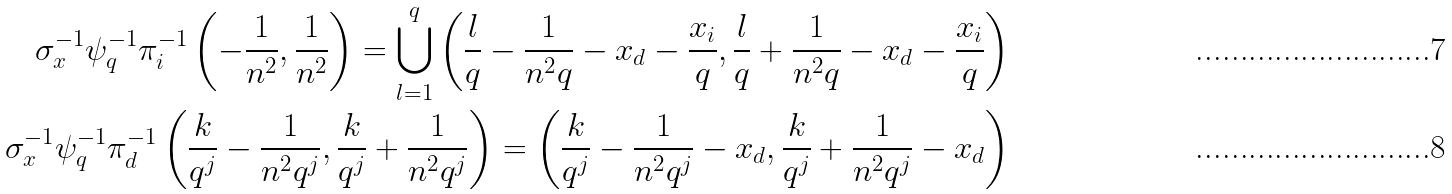Convert formula to latex. <formula><loc_0><loc_0><loc_500><loc_500>\sigma _ { x } ^ { - 1 } \psi _ { q } ^ { - 1 } \pi _ { i } ^ { - 1 } \left ( - \frac { 1 } { n ^ { 2 } } , \frac { 1 } { n ^ { 2 } } \right ) = \bigcup _ { l = 1 } ^ { q } \left ( \frac { l } { q } - \frac { 1 } { n ^ { 2 } q } - x _ { d } - \frac { x _ { i } } { q } , \frac { l } { q } + \frac { 1 } { n ^ { 2 } q } - x _ { d } - \frac { x _ { i } } { q } \right ) \\ \sigma _ { x } ^ { - 1 } \psi _ { q } ^ { - 1 } \pi _ { d } ^ { - 1 } \left ( \frac { k } { q ^ { j } } - \frac { 1 } { n ^ { 2 } q ^ { j } } , \frac { k } { q ^ { j } } + \frac { 1 } { n ^ { 2 } q ^ { j } } \right ) = \left ( \frac { k } { q ^ { j } } - \frac { 1 } { n ^ { 2 } q ^ { j } } - x _ { d } , \frac { k } { q ^ { j } } + \frac { 1 } { n ^ { 2 } q ^ { j } } - x _ { d } \right )</formula> 